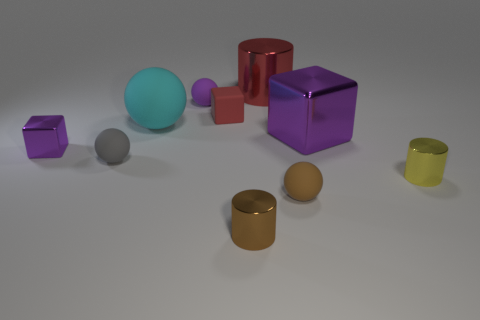Subtract all cubes. How many objects are left? 7 Subtract all small cyan matte blocks. Subtract all brown rubber objects. How many objects are left? 9 Add 9 brown rubber things. How many brown rubber things are left? 10 Add 6 big purple shiny things. How many big purple shiny things exist? 7 Subtract 1 purple balls. How many objects are left? 9 